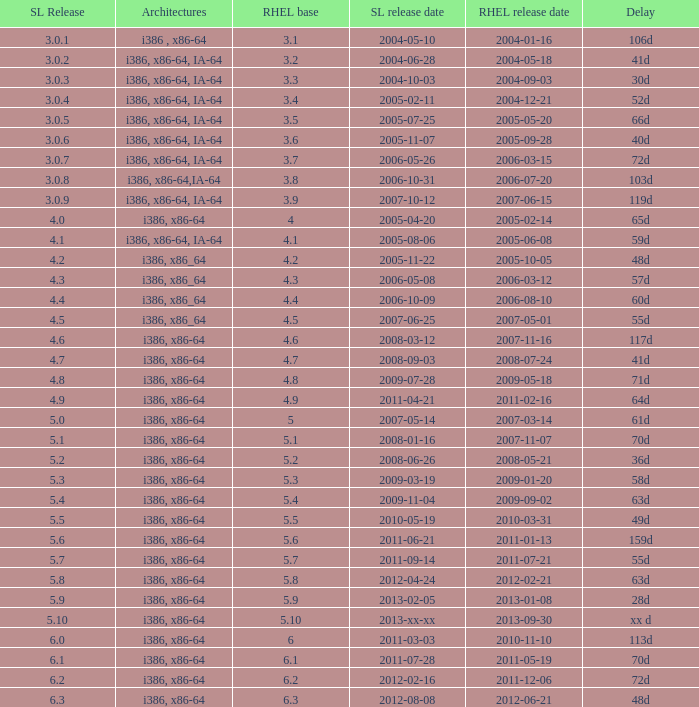I'm looking to parse the entire table for insights. Could you assist me with that? {'header': ['SL Release', 'Architectures', 'RHEL base', 'SL release date', 'RHEL release date', 'Delay'], 'rows': [['3.0.1', 'i386 , x86-64', '3.1', '2004-05-10', '2004-01-16', '106d'], ['3.0.2', 'i386, x86-64, IA-64', '3.2', '2004-06-28', '2004-05-18', '41d'], ['3.0.3', 'i386, x86-64, IA-64', '3.3', '2004-10-03', '2004-09-03', '30d'], ['3.0.4', 'i386, x86-64, IA-64', '3.4', '2005-02-11', '2004-12-21', '52d'], ['3.0.5', 'i386, x86-64, IA-64', '3.5', '2005-07-25', '2005-05-20', '66d'], ['3.0.6', 'i386, x86-64, IA-64', '3.6', '2005-11-07', '2005-09-28', '40d'], ['3.0.7', 'i386, x86-64, IA-64', '3.7', '2006-05-26', '2006-03-15', '72d'], ['3.0.8', 'i386, x86-64,IA-64', '3.8', '2006-10-31', '2006-07-20', '103d'], ['3.0.9', 'i386, x86-64, IA-64', '3.9', '2007-10-12', '2007-06-15', '119d'], ['4.0', 'i386, x86-64', '4', '2005-04-20', '2005-02-14', '65d'], ['4.1', 'i386, x86-64, IA-64', '4.1', '2005-08-06', '2005-06-08', '59d'], ['4.2', 'i386, x86_64', '4.2', '2005-11-22', '2005-10-05', '48d'], ['4.3', 'i386, x86_64', '4.3', '2006-05-08', '2006-03-12', '57d'], ['4.4', 'i386, x86_64', '4.4', '2006-10-09', '2006-08-10', '60d'], ['4.5', 'i386, x86_64', '4.5', '2007-06-25', '2007-05-01', '55d'], ['4.6', 'i386, x86-64', '4.6', '2008-03-12', '2007-11-16', '117d'], ['4.7', 'i386, x86-64', '4.7', '2008-09-03', '2008-07-24', '41d'], ['4.8', 'i386, x86-64', '4.8', '2009-07-28', '2009-05-18', '71d'], ['4.9', 'i386, x86-64', '4.9', '2011-04-21', '2011-02-16', '64d'], ['5.0', 'i386, x86-64', '5', '2007-05-14', '2007-03-14', '61d'], ['5.1', 'i386, x86-64', '5.1', '2008-01-16', '2007-11-07', '70d'], ['5.2', 'i386, x86-64', '5.2', '2008-06-26', '2008-05-21', '36d'], ['5.3', 'i386, x86-64', '5.3', '2009-03-19', '2009-01-20', '58d'], ['5.4', 'i386, x86-64', '5.4', '2009-11-04', '2009-09-02', '63d'], ['5.5', 'i386, x86-64', '5.5', '2010-05-19', '2010-03-31', '49d'], ['5.6', 'i386, x86-64', '5.6', '2011-06-21', '2011-01-13', '159d'], ['5.7', 'i386, x86-64', '5.7', '2011-09-14', '2011-07-21', '55d'], ['5.8', 'i386, x86-64', '5.8', '2012-04-24', '2012-02-21', '63d'], ['5.9', 'i386, x86-64', '5.9', '2013-02-05', '2013-01-08', '28d'], ['5.10', 'i386, x86-64', '5.10', '2013-xx-xx', '2013-09-30', 'xx d'], ['6.0', 'i386, x86-64', '6', '2011-03-03', '2010-11-10', '113d'], ['6.1', 'i386, x86-64', '6.1', '2011-07-28', '2011-05-19', '70d'], ['6.2', 'i386, x86-64', '6.2', '2012-02-16', '2011-12-06', '72d'], ['6.3', 'i386, x86-64', '6.3', '2012-08-08', '2012-06-21', '48d']]} Name the scientific linux release when delay is 28d 5.9. 